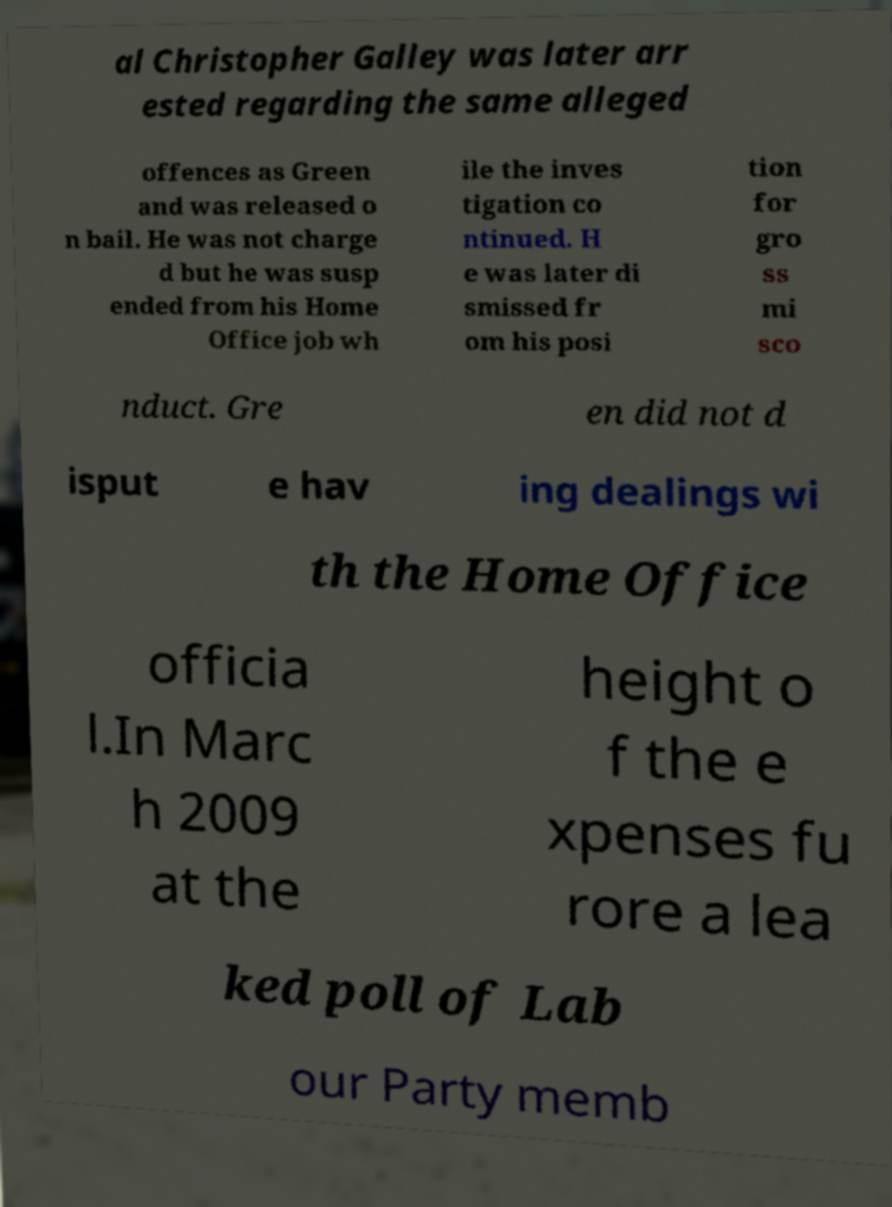I need the written content from this picture converted into text. Can you do that? al Christopher Galley was later arr ested regarding the same alleged offences as Green and was released o n bail. He was not charge d but he was susp ended from his Home Office job wh ile the inves tigation co ntinued. H e was later di smissed fr om his posi tion for gro ss mi sco nduct. Gre en did not d isput e hav ing dealings wi th the Home Office officia l.In Marc h 2009 at the height o f the e xpenses fu rore a lea ked poll of Lab our Party memb 